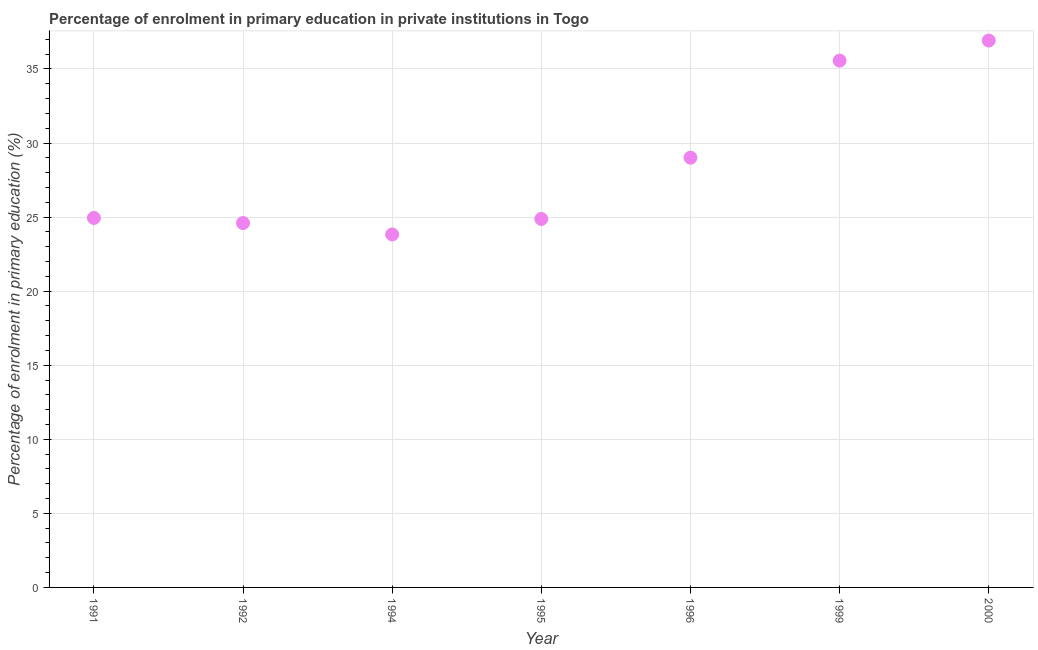What is the enrolment percentage in primary education in 1995?
Keep it short and to the point. 24.87. Across all years, what is the maximum enrolment percentage in primary education?
Keep it short and to the point. 36.92. Across all years, what is the minimum enrolment percentage in primary education?
Your response must be concise. 23.83. In which year was the enrolment percentage in primary education maximum?
Make the answer very short. 2000. In which year was the enrolment percentage in primary education minimum?
Your response must be concise. 1994. What is the sum of the enrolment percentage in primary education?
Your response must be concise. 199.74. What is the difference between the enrolment percentage in primary education in 1992 and 1994?
Ensure brevity in your answer.  0.77. What is the average enrolment percentage in primary education per year?
Ensure brevity in your answer.  28.53. What is the median enrolment percentage in primary education?
Provide a succinct answer. 24.94. In how many years, is the enrolment percentage in primary education greater than 11 %?
Offer a terse response. 7. What is the ratio of the enrolment percentage in primary education in 1992 to that in 1994?
Offer a very short reply. 1.03. Is the difference between the enrolment percentage in primary education in 1991 and 1992 greater than the difference between any two years?
Provide a short and direct response. No. What is the difference between the highest and the second highest enrolment percentage in primary education?
Ensure brevity in your answer.  1.36. Is the sum of the enrolment percentage in primary education in 1991 and 1996 greater than the maximum enrolment percentage in primary education across all years?
Offer a terse response. Yes. What is the difference between the highest and the lowest enrolment percentage in primary education?
Offer a terse response. 13.09. In how many years, is the enrolment percentage in primary education greater than the average enrolment percentage in primary education taken over all years?
Give a very brief answer. 3. Are the values on the major ticks of Y-axis written in scientific E-notation?
Provide a short and direct response. No. Does the graph contain any zero values?
Offer a terse response. No. Does the graph contain grids?
Your answer should be compact. Yes. What is the title of the graph?
Offer a terse response. Percentage of enrolment in primary education in private institutions in Togo. What is the label or title of the X-axis?
Ensure brevity in your answer.  Year. What is the label or title of the Y-axis?
Offer a terse response. Percentage of enrolment in primary education (%). What is the Percentage of enrolment in primary education (%) in 1991?
Your answer should be compact. 24.94. What is the Percentage of enrolment in primary education (%) in 1992?
Provide a succinct answer. 24.6. What is the Percentage of enrolment in primary education (%) in 1994?
Your response must be concise. 23.83. What is the Percentage of enrolment in primary education (%) in 1995?
Your answer should be very brief. 24.87. What is the Percentage of enrolment in primary education (%) in 1996?
Your response must be concise. 29.01. What is the Percentage of enrolment in primary education (%) in 1999?
Provide a succinct answer. 35.56. What is the Percentage of enrolment in primary education (%) in 2000?
Your answer should be very brief. 36.92. What is the difference between the Percentage of enrolment in primary education (%) in 1991 and 1992?
Give a very brief answer. 0.34. What is the difference between the Percentage of enrolment in primary education (%) in 1991 and 1994?
Ensure brevity in your answer.  1.11. What is the difference between the Percentage of enrolment in primary education (%) in 1991 and 1995?
Ensure brevity in your answer.  0.07. What is the difference between the Percentage of enrolment in primary education (%) in 1991 and 1996?
Keep it short and to the point. -4.07. What is the difference between the Percentage of enrolment in primary education (%) in 1991 and 1999?
Give a very brief answer. -10.62. What is the difference between the Percentage of enrolment in primary education (%) in 1991 and 2000?
Your answer should be very brief. -11.98. What is the difference between the Percentage of enrolment in primary education (%) in 1992 and 1994?
Provide a short and direct response. 0.77. What is the difference between the Percentage of enrolment in primary education (%) in 1992 and 1995?
Your answer should be very brief. -0.28. What is the difference between the Percentage of enrolment in primary education (%) in 1992 and 1996?
Your answer should be very brief. -4.41. What is the difference between the Percentage of enrolment in primary education (%) in 1992 and 1999?
Provide a succinct answer. -10.97. What is the difference between the Percentage of enrolment in primary education (%) in 1992 and 2000?
Offer a very short reply. -12.32. What is the difference between the Percentage of enrolment in primary education (%) in 1994 and 1995?
Make the answer very short. -1.05. What is the difference between the Percentage of enrolment in primary education (%) in 1994 and 1996?
Make the answer very short. -5.18. What is the difference between the Percentage of enrolment in primary education (%) in 1994 and 1999?
Keep it short and to the point. -11.73. What is the difference between the Percentage of enrolment in primary education (%) in 1994 and 2000?
Ensure brevity in your answer.  -13.09. What is the difference between the Percentage of enrolment in primary education (%) in 1995 and 1996?
Make the answer very short. -4.14. What is the difference between the Percentage of enrolment in primary education (%) in 1995 and 1999?
Give a very brief answer. -10.69. What is the difference between the Percentage of enrolment in primary education (%) in 1995 and 2000?
Offer a terse response. -12.05. What is the difference between the Percentage of enrolment in primary education (%) in 1996 and 1999?
Your answer should be very brief. -6.55. What is the difference between the Percentage of enrolment in primary education (%) in 1996 and 2000?
Provide a succinct answer. -7.91. What is the difference between the Percentage of enrolment in primary education (%) in 1999 and 2000?
Make the answer very short. -1.36. What is the ratio of the Percentage of enrolment in primary education (%) in 1991 to that in 1992?
Ensure brevity in your answer.  1.01. What is the ratio of the Percentage of enrolment in primary education (%) in 1991 to that in 1994?
Offer a very short reply. 1.05. What is the ratio of the Percentage of enrolment in primary education (%) in 1991 to that in 1995?
Provide a succinct answer. 1. What is the ratio of the Percentage of enrolment in primary education (%) in 1991 to that in 1996?
Ensure brevity in your answer.  0.86. What is the ratio of the Percentage of enrolment in primary education (%) in 1991 to that in 1999?
Offer a very short reply. 0.7. What is the ratio of the Percentage of enrolment in primary education (%) in 1991 to that in 2000?
Offer a very short reply. 0.68. What is the ratio of the Percentage of enrolment in primary education (%) in 1992 to that in 1994?
Your answer should be very brief. 1.03. What is the ratio of the Percentage of enrolment in primary education (%) in 1992 to that in 1996?
Your response must be concise. 0.85. What is the ratio of the Percentage of enrolment in primary education (%) in 1992 to that in 1999?
Your answer should be very brief. 0.69. What is the ratio of the Percentage of enrolment in primary education (%) in 1992 to that in 2000?
Make the answer very short. 0.67. What is the ratio of the Percentage of enrolment in primary education (%) in 1994 to that in 1995?
Provide a short and direct response. 0.96. What is the ratio of the Percentage of enrolment in primary education (%) in 1994 to that in 1996?
Keep it short and to the point. 0.82. What is the ratio of the Percentage of enrolment in primary education (%) in 1994 to that in 1999?
Give a very brief answer. 0.67. What is the ratio of the Percentage of enrolment in primary education (%) in 1994 to that in 2000?
Provide a succinct answer. 0.65. What is the ratio of the Percentage of enrolment in primary education (%) in 1995 to that in 1996?
Give a very brief answer. 0.86. What is the ratio of the Percentage of enrolment in primary education (%) in 1995 to that in 1999?
Keep it short and to the point. 0.7. What is the ratio of the Percentage of enrolment in primary education (%) in 1995 to that in 2000?
Offer a terse response. 0.67. What is the ratio of the Percentage of enrolment in primary education (%) in 1996 to that in 1999?
Provide a short and direct response. 0.82. What is the ratio of the Percentage of enrolment in primary education (%) in 1996 to that in 2000?
Provide a succinct answer. 0.79. 